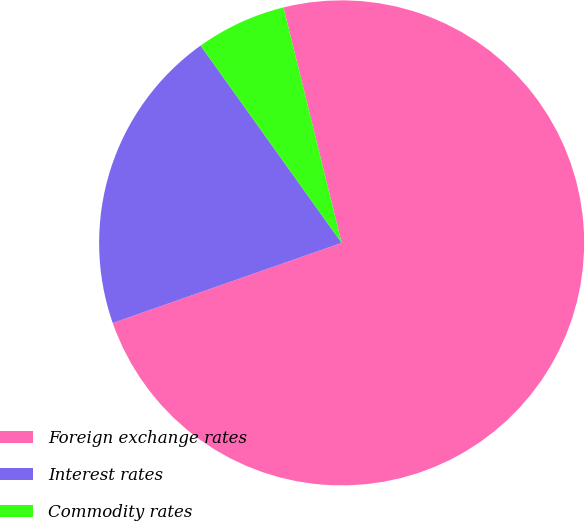<chart> <loc_0><loc_0><loc_500><loc_500><pie_chart><fcel>Foreign exchange rates<fcel>Interest rates<fcel>Commodity rates<nl><fcel>73.49%<fcel>20.48%<fcel>6.02%<nl></chart> 